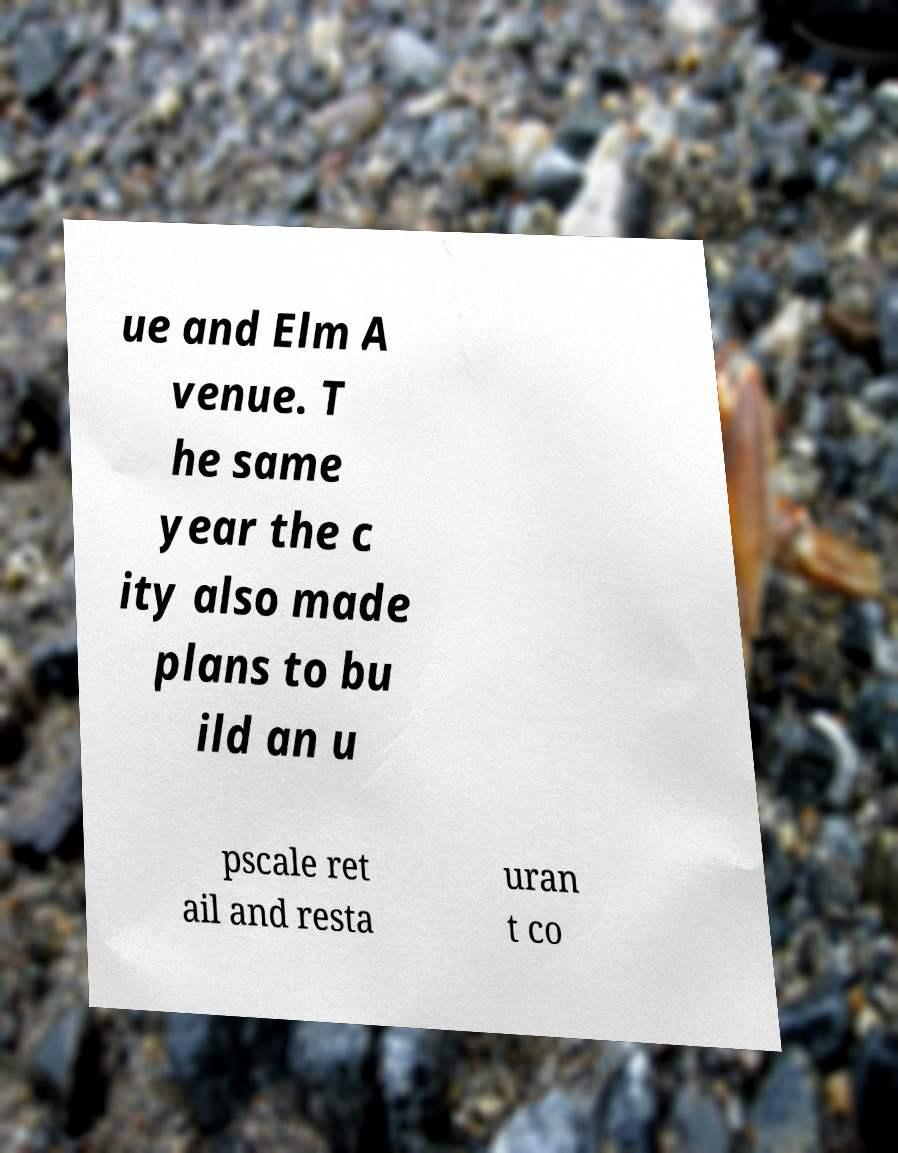Please read and relay the text visible in this image. What does it say? ue and Elm A venue. T he same year the c ity also made plans to bu ild an u pscale ret ail and resta uran t co 